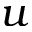<formula> <loc_0><loc_0><loc_500><loc_500>u</formula> 